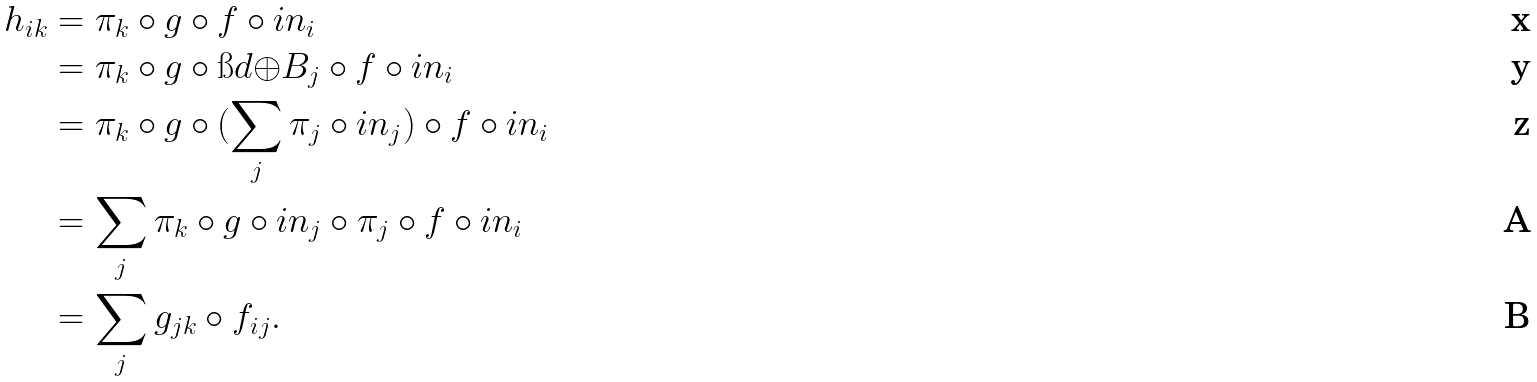Convert formula to latex. <formula><loc_0><loc_0><loc_500><loc_500>h _ { i k } & = \pi _ { k } \circ g \circ f \circ i n _ { i } \\ & = \pi _ { k } \circ g \circ \i d { \oplus B _ { j } } \circ f \circ i n _ { i } \\ & = \pi _ { k } \circ g \circ ( \sum _ { j } \pi _ { j } \circ i n _ { j } ) \circ f \circ i n _ { i } \\ & = \sum _ { j } \pi _ { k } \circ g \circ i n _ { j } \circ \pi _ { j } \circ f \circ i n _ { i } \\ & = \sum _ { j } g _ { j k } \circ f _ { i j } .</formula> 